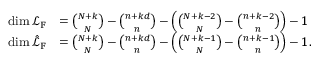Convert formula to latex. <formula><loc_0><loc_0><loc_500><loc_500>\begin{array} { r l } { \dim \mathcal { L } _ { \mathbb { F } } } & { = { \binom { N + k } { N } } - { \binom { n + k d } { n } } - \left ( { \binom { N + k - 2 } { N } } - { \binom { n + k - 2 } { n } } \right ) - 1 } \\ { \dim \hat { \mathcal { L } } _ { \mathbb { F } } } & { = { \binom { N + k } { N } } - { \binom { n + k d } { n } } - \left ( { \binom { N + k - 1 } { N } } - { \binom { n + k - 1 } { n } } \right ) - 1 . } \end{array}</formula> 